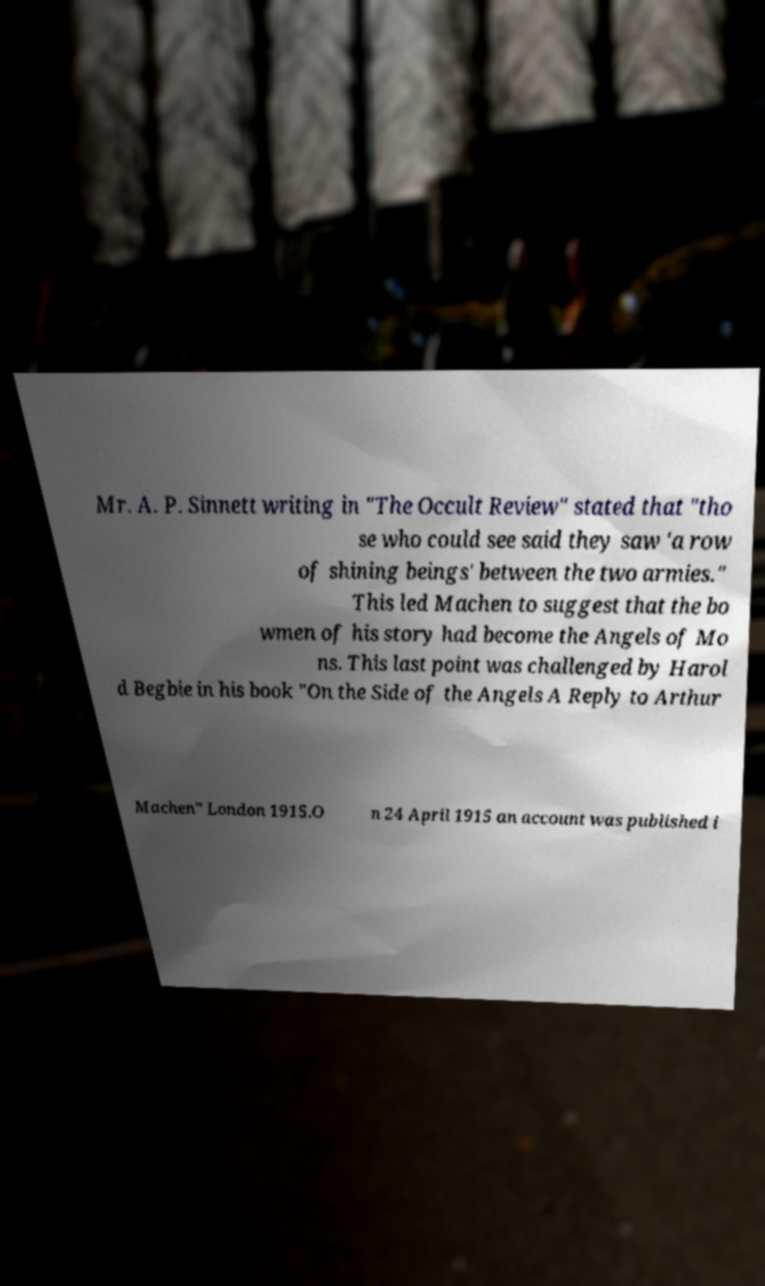Can you read and provide the text displayed in the image?This photo seems to have some interesting text. Can you extract and type it out for me? Mr. A. P. Sinnett writing in "The Occult Review" stated that "tho se who could see said they saw 'a row of shining beings' between the two armies." This led Machen to suggest that the bo wmen of his story had become the Angels of Mo ns. This last point was challenged by Harol d Begbie in his book "On the Side of the Angels A Reply to Arthur Machen" London 1915.O n 24 April 1915 an account was published i 